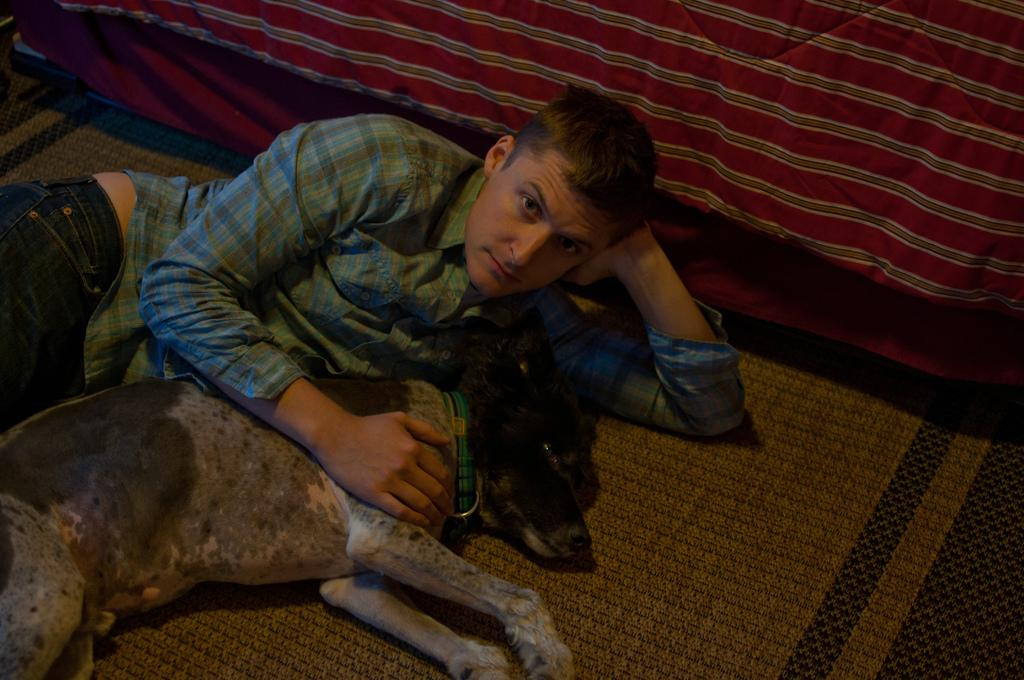Who or what is present in the image? There is a person and a dog in the image. What is the position of the person in the image? The person is laying on the floor. What is the position of the dog in the image? The dog is laying on the floor. What can be seen in the background of the image? There is a bed in the background of the image. What type of seed is the dog planting in the image? There is no seed or planting activity present in the image. Can you describe the door in the image? There is no door present in the image. 